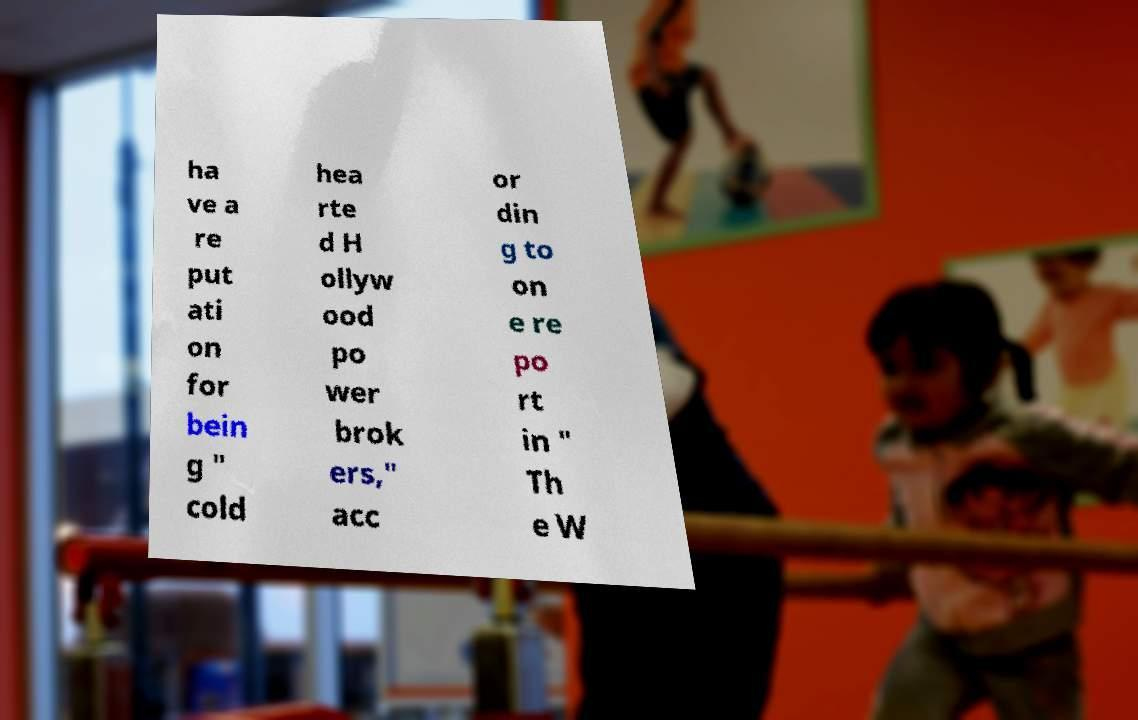What messages or text are displayed in this image? I need them in a readable, typed format. ha ve a re put ati on for bein g " cold hea rte d H ollyw ood po wer brok ers," acc or din g to on e re po rt in " Th e W 